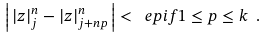Convert formula to latex. <formula><loc_0><loc_0><loc_500><loc_500>\left | \, | z | _ { j } ^ { n } - | z | _ { j + n p } ^ { n } \, \right | < \ e p i f 1 \leq p \leq k \ .</formula> 